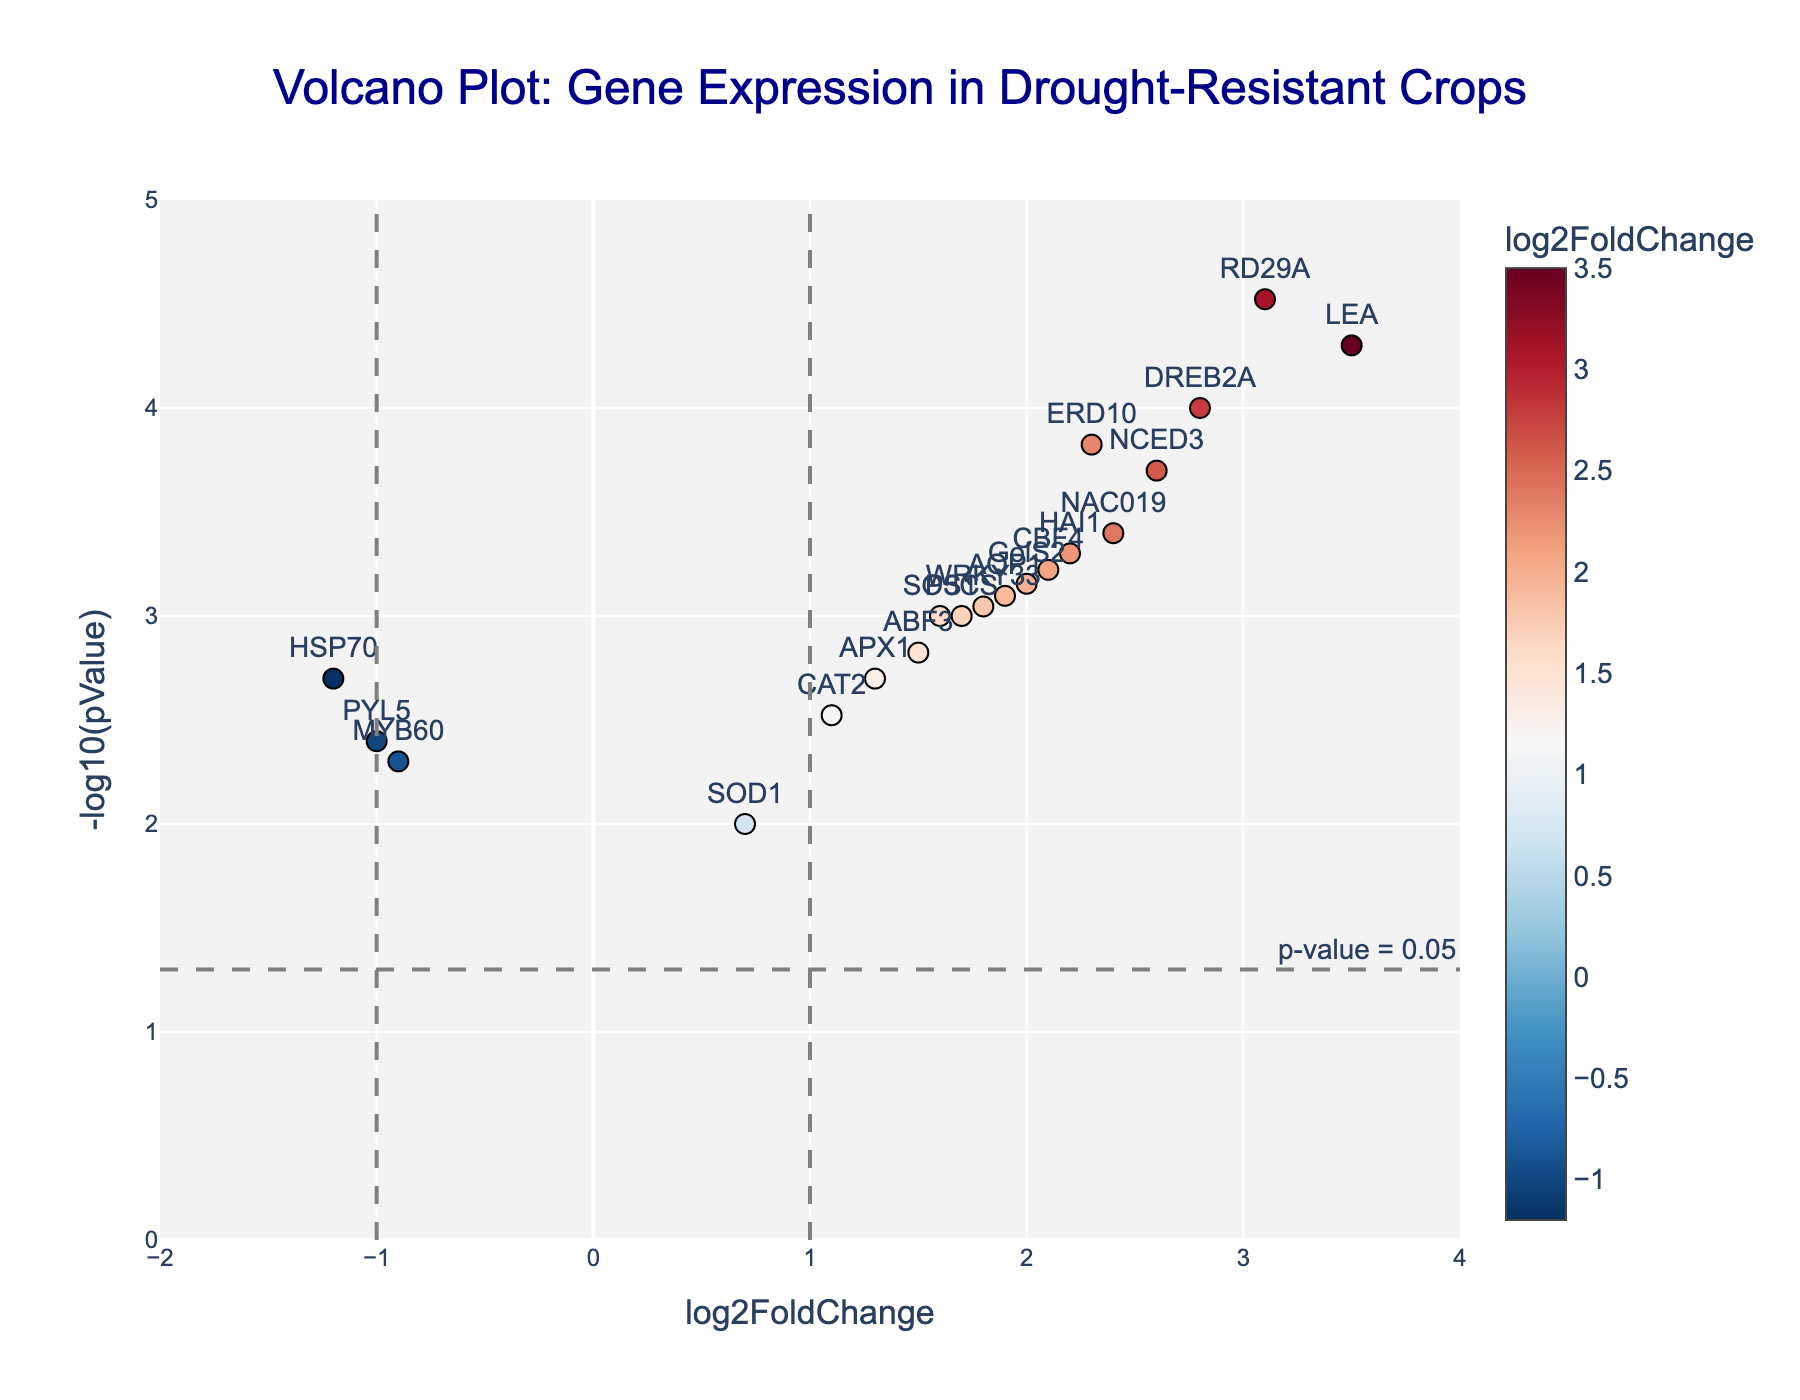What is the title of the plot? The title is located at the top center of the plot and is meant to provide a quick overview of the subject matter.
Answer: Volcano Plot: Gene Expression in Drought-Resistant Crops What do the x-axis and y-axis represent? The x-axis is labeled "log2FoldChange," indicating the fold change in gene expression on a log base 2 scale. The y-axis is labeled "-log10(pValue)," showing the p-value transformed to a negative log base 10 scale.
Answer: log2FoldChange and -log10(pValue) Which genes have a log2FoldChange greater than 2 and a -log10(pValue) greater than 4? By examining the plot, find the genes that satisfy both conditions: having a log2FoldChange greater than 2 and a -log10(pValue) above 4. Only the genes LEA and RD29A fit these criteria.
Answer: LEA and RD29A Are there any genes with a negative log2FoldChange that are still statistically significant (p-value below 0.05)? To find these genes, look for points on the left side of the plot (negative x-axis) that are above the p-value significance line at -log10(pValue) = 1.3. These genes are HSP70, MYB60, and PYL5.
Answer: HSP70, MYB60, and PYL5 Which gene has the highest -log10(pValue) and what is its log2FoldChange? Identify the gene at the highest point on the y-axis, which is RD29A with a -log10(pValue) approximately 4.52 and log2FoldChange of 3.1.
Answer: RD29A, 3.1 Compare the log2FoldChange of DREB2A and AQP1. Which one is higher? Compare the x-axis values for DREB2A and AQP1. DREB2A has a log2FoldChange of 2.8, whereas AQP1 has a log2FoldChange of 1.9, so DREB2A is higher.
Answer: DREB2A How many genes have a -log10(pValue) greater than 2? Count all the points above the y-axis value of 2. These genes are DREB2A, LEA, RD29A, and NCED3, totaling 4 genes.
Answer: 4 genes Which gene is closest to the vertical line at log2FoldChange = 1? Identify the gene closest to the vertical line at x=1. The closest gene is CAT2 with a log2FoldChange of 1.1.
Answer: CAT2 Is there a trend in the distribution of log2FoldChange values among the most statistically significant genes? Assess whether the most statistically significant genes (higher in y-axis) show a certain trend in log2FoldChange. The trend is that highly significant genes usually have a significant positive log2FoldChange.
Answer: Positive trend 